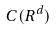<formula> <loc_0><loc_0><loc_500><loc_500>C ( R ^ { d } )</formula> 